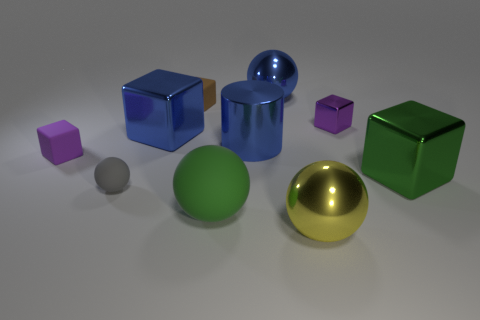Are there any cylinders that are in front of the sphere that is behind the small purple block that is left of the blue block?
Your answer should be compact. Yes. There is a purple object that is behind the blue block; does it have the same shape as the green thing that is in front of the gray matte sphere?
Provide a short and direct response. No. Are there more tiny matte things behind the purple rubber cube than red spheres?
Offer a terse response. Yes. How many objects are either blue spheres or large cyan cubes?
Give a very brief answer. 1. What is the color of the large matte ball?
Provide a succinct answer. Green. What number of other objects are there of the same color as the small matte sphere?
Give a very brief answer. 0. Are there any small cubes to the right of the brown rubber block?
Provide a short and direct response. Yes. What is the color of the metal ball that is in front of the purple block that is on the left side of the large blue metal object that is in front of the blue shiny cube?
Make the answer very short. Yellow. How many shiny things are both on the right side of the small brown rubber cube and behind the blue cylinder?
Your response must be concise. 2. How many balls are either big objects or large yellow metal objects?
Make the answer very short. 3. 